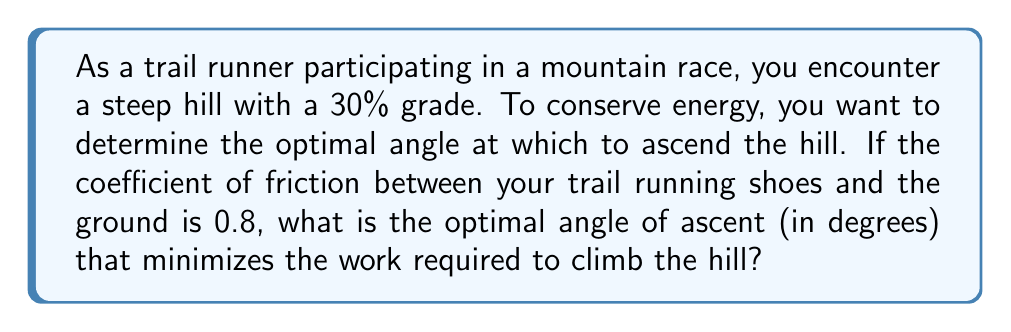Solve this math problem. Let's approach this step-by-step:

1) The optimal angle of ascent is the one that minimizes the work done against friction while climbing the hill. This occurs when the normal force is minimized.

2) The grade of the hill is 30%, which means the angle of the hill (θ) can be calculated as:
   
   $\tan \theta = 0.30$
   $\theta = \arctan(0.30) \approx 16.7°$

3) Let's define φ as the angle between the runner's path and the horizontal. The optimal φ will be our answer.

4) The normal force (N) acting on the runner is given by:
   
   $N = mg \cos(\theta - \phi)$

   Where m is the mass of the runner and g is the acceleration due to gravity.

5) The frictional force (F) is given by:
   
   $F = \mu N = \mu mg \cos(\theta - \phi)$

   Where μ is the coefficient of friction (0.8 in this case).

6) To minimize the work done against friction, we need to minimize F, which is equivalent to minimizing $\cos(\theta - \phi)$.

7) The minimum value of cosine occurs when its argument is 90°. Therefore:

   $\theta - \phi = 90°$

8) Solving for φ:

   $\phi = \theta - 90°$

9) Substituting the value of θ we calculated earlier:

   $\phi = 16.7° - 90° = -73.3°$

10) The negative angle doesn't make physical sense for ascent, so we take the absolute value:

    $\phi = 73.3°$

This is the optimal angle of ascent relative to the horizontal.
Answer: 73.3° 